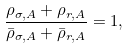<formula> <loc_0><loc_0><loc_500><loc_500>\frac { \rho _ { \sigma , A } + \rho _ { r , A } } { \bar { \rho } _ { \sigma , A } + \bar { \rho } _ { r , A } } = 1 ,</formula> 